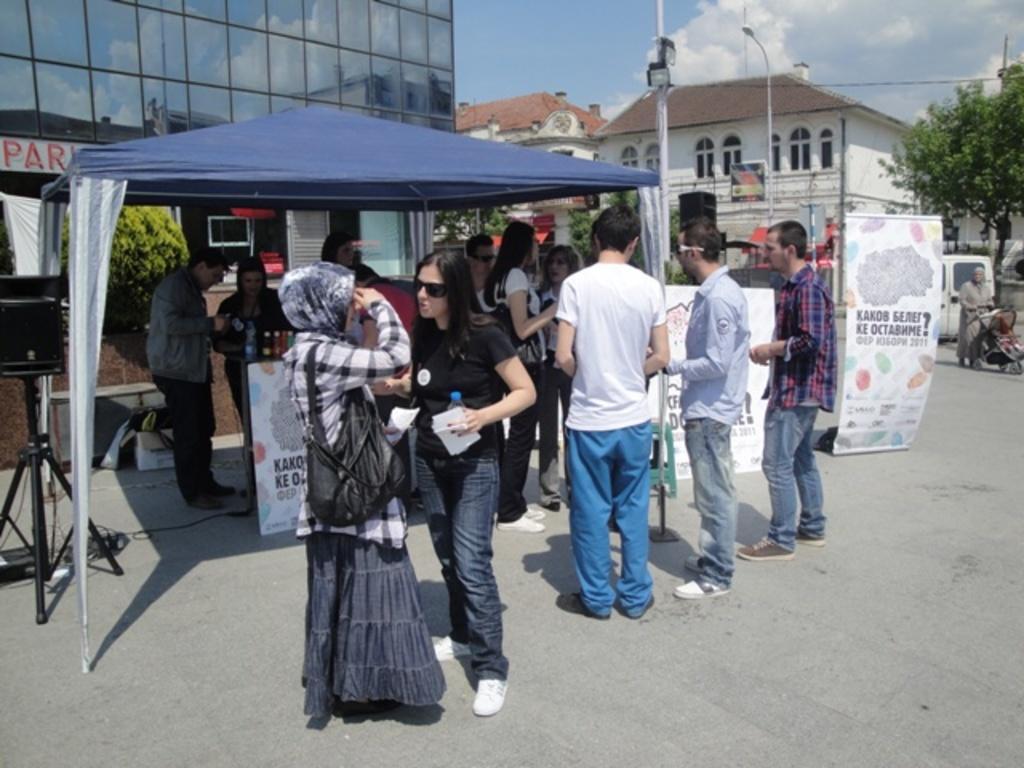Could you give a brief overview of what you see in this image? In this image there are people standing under the tent and few are standing on the road and there are banners, on that banners there is some text, in the background there are trees, light poles, houses and the sky. 